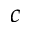<formula> <loc_0><loc_0><loc_500><loc_500>c</formula> 